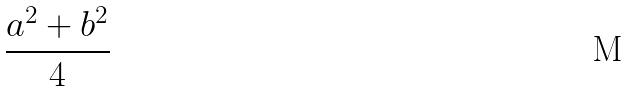Convert formula to latex. <formula><loc_0><loc_0><loc_500><loc_500>\frac { a ^ { 2 } + b ^ { 2 } } { 4 }</formula> 